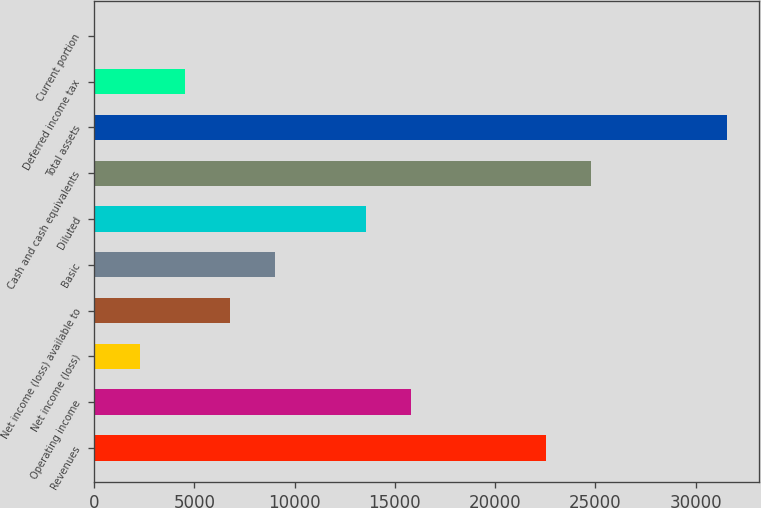Convert chart. <chart><loc_0><loc_0><loc_500><loc_500><bar_chart><fcel>Revenues<fcel>Operating income<fcel>Net income (loss)<fcel>Net income (loss) available to<fcel>Basic<fcel>Diluted<fcel>Cash and cash equivalents<fcel>Total assets<fcel>Deferred income tax<fcel>Current portion<nl><fcel>22555<fcel>15797.5<fcel>2282.5<fcel>6787.5<fcel>9040<fcel>13545<fcel>24807.5<fcel>31565<fcel>4535<fcel>30<nl></chart> 